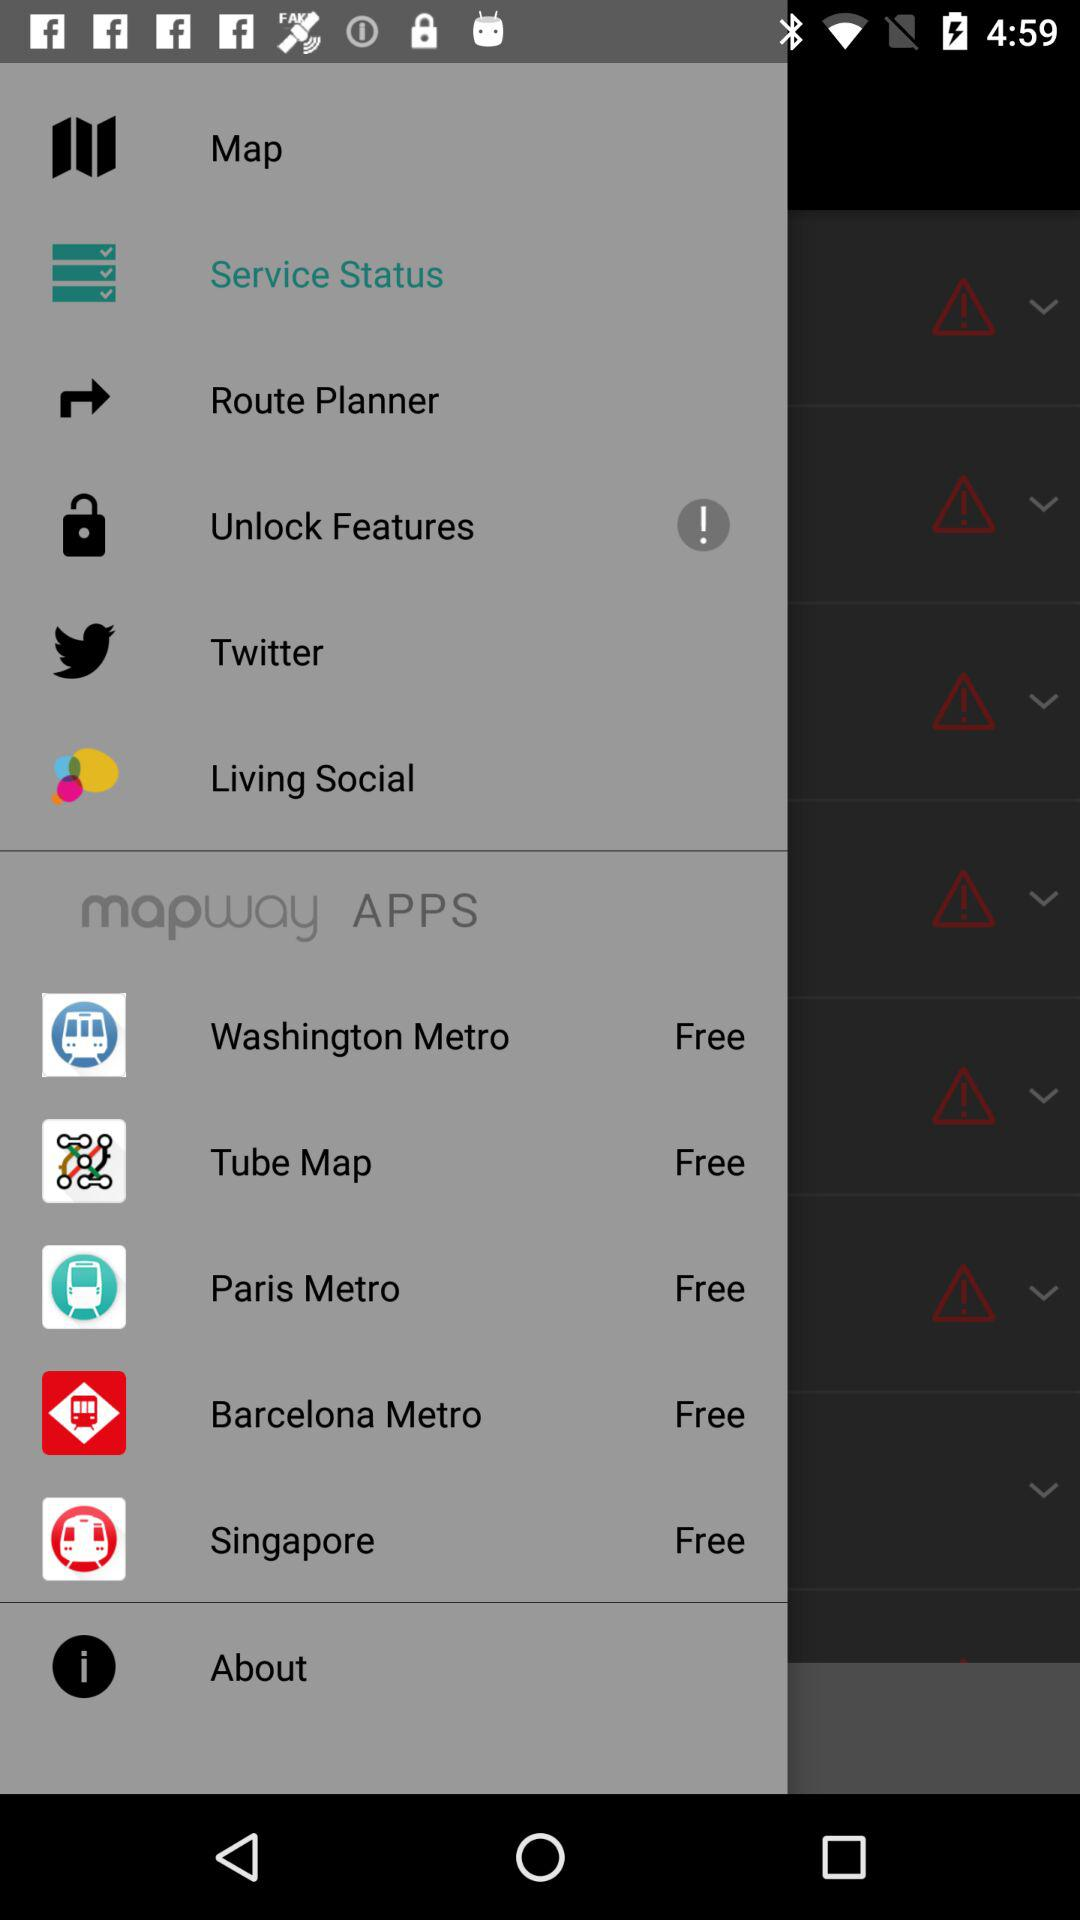Which option is selected? The selected option is "Service Status". 